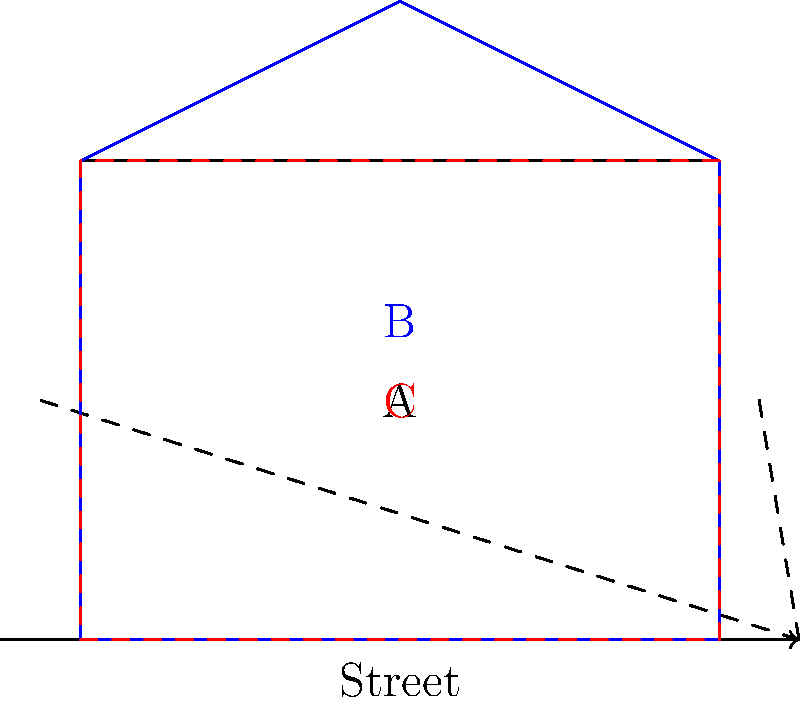As a small business owner planning to open a boutique store, you are comparing different storefront designs for visibility from the street. The image shows three storefront designs (A, B, and C) with the same width but different shapes. Based on the 2D elevation views and sightlines shown, which design would likely offer the best visibility from various angles along the street? To determine which storefront design offers the best visibility, we need to consider the following factors:

1. Shape and height: 
   - Design A is a rectangular shape with a flat roof.
   - Design B has a peaked roof, extending higher than the other designs.
   - Design C is similar to A but with an angled facade.

2. Sightlines:
   - The dashed lines represent sightlines from different positions on the street.
   - These sightlines help us understand how the storefronts appear from various angles.

3. Visibility analysis:
   - Design A: Offers consistent visibility but may not stand out.
   - Design B: The peaked roof extends beyond the sightlines, making it more noticeable from a distance.
   - Design C: The angled facade may offer slightly better visibility than A, but less than B.

4. Street-level impact:
   - Design B's unique shape is likely to catch more attention from pedestrians and drivers.
   - The higher peak of Design B increases its visibility over a longer distance along the street.

5. Overall prominence:
   - Design B's extended height and unique shape make it the most prominent among the three options.
   - It breaks the typical storefront silhouette, potentially drawing more attention.

Considering these factors, Design B would likely offer the best visibility from various angles along the street due to its extended height and distinctive shape.
Answer: Design B 